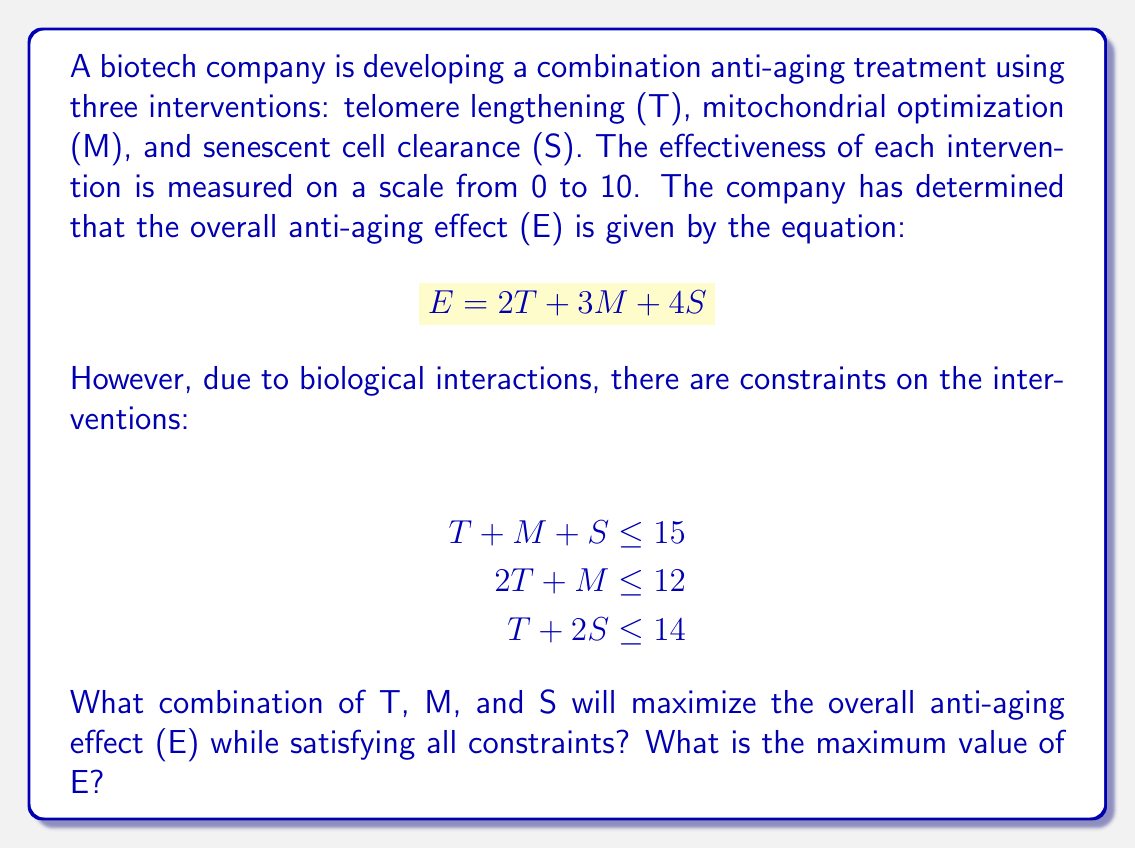Can you solve this math problem? To solve this optimization problem, we'll use the method of linear programming:

1) First, we need to identify our objective function and constraints:

   Objective function: Maximize $$E = 2T + 3M + 4S$$
   Constraints: 
   $$T + M + S \leq 15$$
   $$2T + M \leq 12$$
   $$T + 2S \leq 14$$
   $$T, M, S \geq 0$$ (non-negativity constraint)

2) We can solve this graphically or using the simplex method. For simplicity, we'll use the graphical method.

3) Plot the constraints in the TS-plane for different values of M:

   [asy]
   import graph;
   size(200);
   xaxis("T", 0, 15, Arrow);
   yaxis("S", 0, 15, Arrow);
   draw((0,7)--(14,0), blue);
   draw((0,15)--(15,0), red);
   draw((6,0)--(0,6), green);
   label("T+2S=14", (7,3.5), E);
   label("T+S=15-M", (7.5,7.5), NE);
   label("2T+M=12", (3,3), W);
   dot((6,4));
   label("(6,4)", (6,4), SE);
   [/asy]

4) The feasible region is the area bounded by these lines and the axes.

5) The optimal solution will be at one of the corner points of this region. We need to test each corner point:

   Point 1 (0,6): E = 2(0) + 3(3) + 4(6) = 33
   Point 2 (6,4): E = 2(6) + 3(5) + 4(4) = 43
   Point 3 (12,0): E = 2(12) + 3(0) + 4(0) = 24

6) The maximum value of E occurs at the point (6,4), where T=6 and S=4.

7) To find M, we can substitute these values into the first constraint:
   $$6 + M + 4 = 15$$
   $$M = 5$$

Therefore, the optimal combination is T=6, M=5, S=4, which gives a maximum E of 43.
Answer: T=6, M=5, S=4; E_max=43 